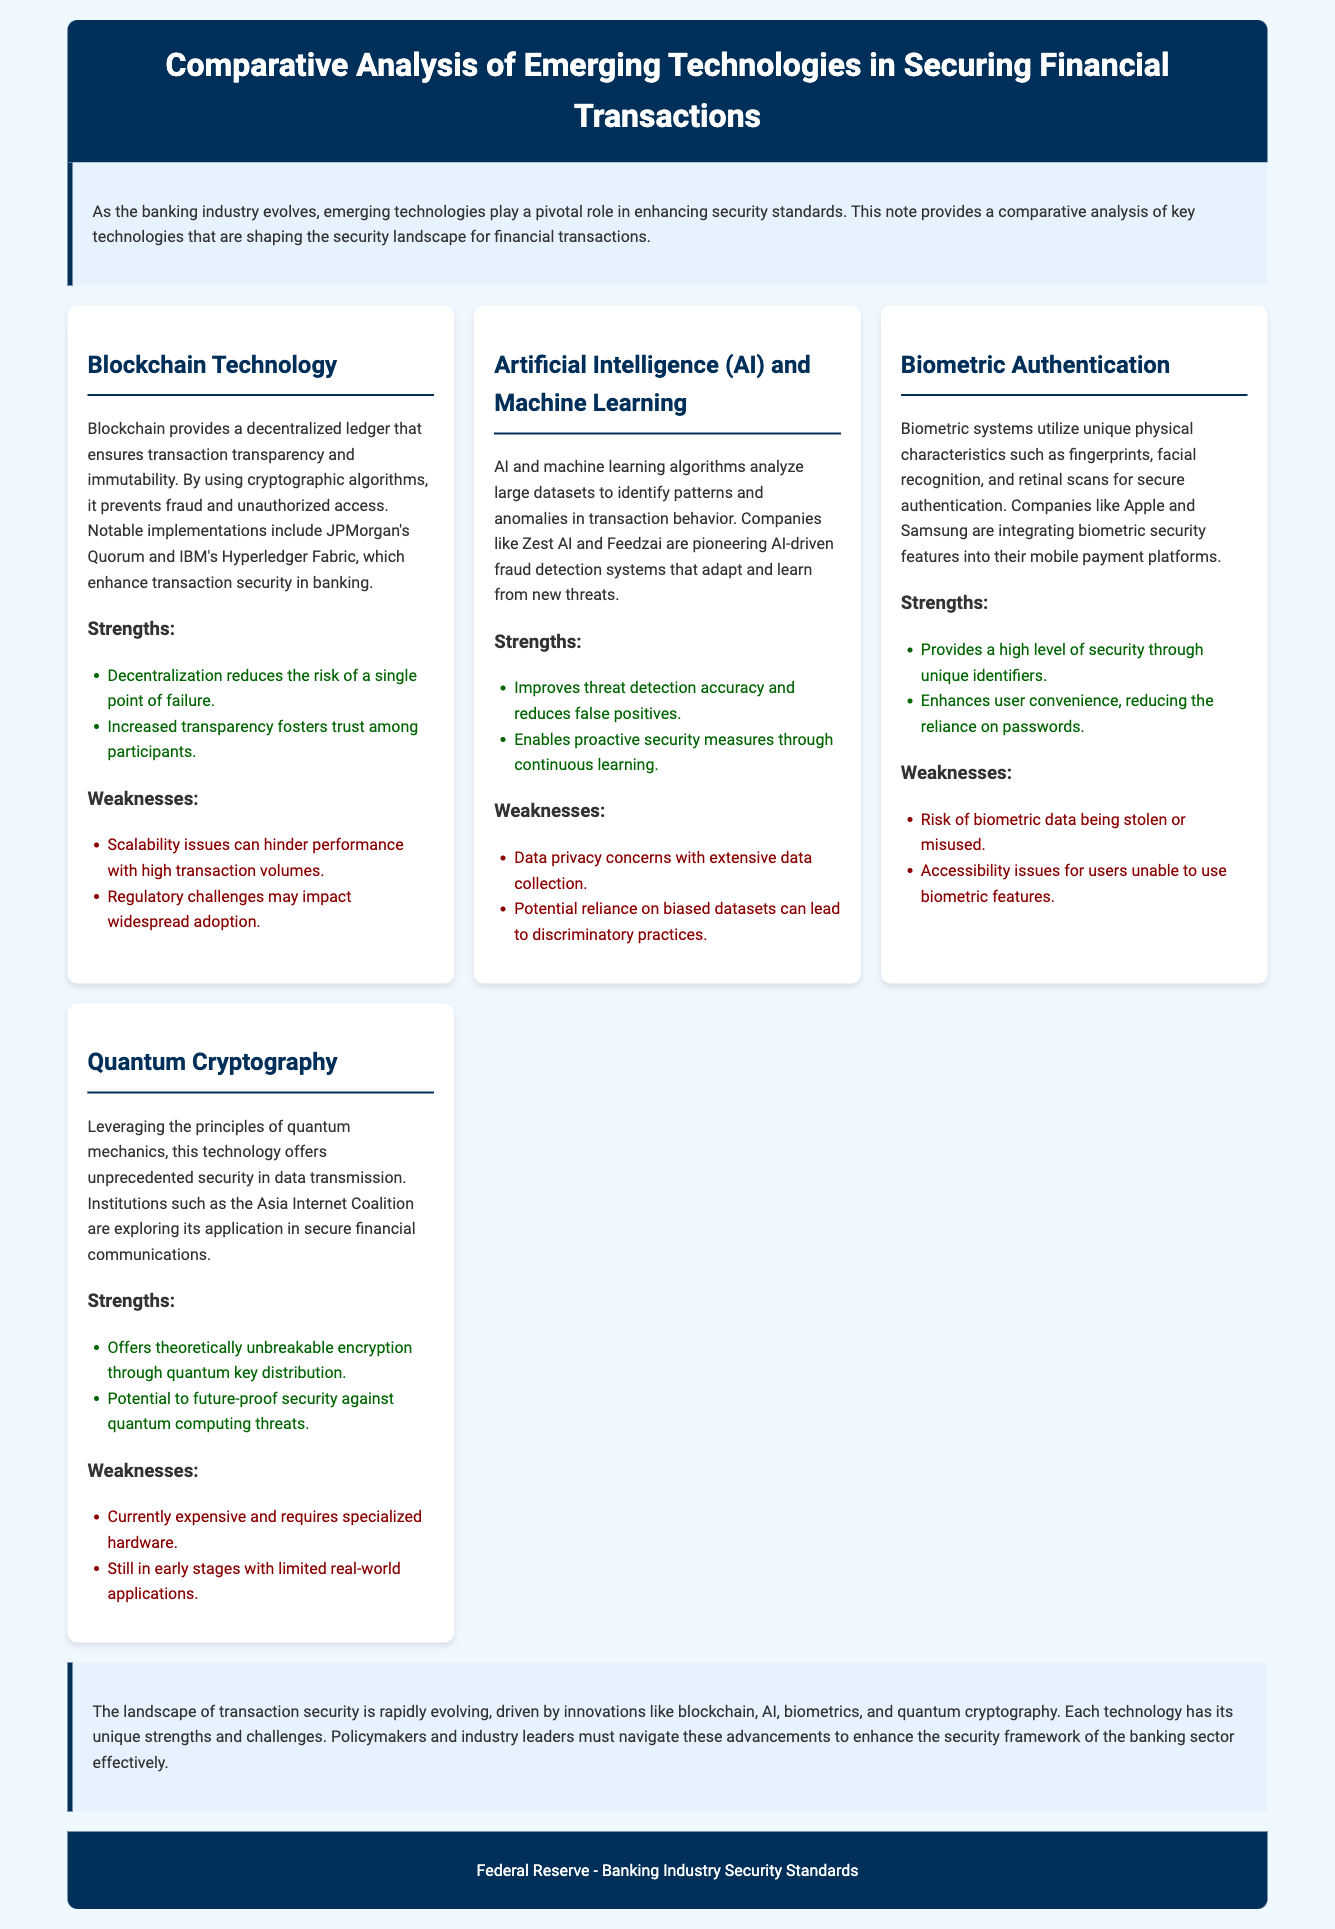What is the primary focus of the note? The primary focus is the comparative analysis of emerging technologies that enhance security standards in the banking industry.
Answer: Comparative analysis of emerging technologies in securing financial transactions Which technology ensures transaction transparency and immutability? Blockchain provides a decentralized ledger that ensures transaction transparency and immutability.
Answer: Blockchain What is a notable implementation of AI in fraud detection? Companies like Zest AI and Feedzai are pioneering AI-driven fraud detection systems.
Answer: Zest AI and Feedzai What is the risk associated with biometric authentication? The risk includes biometric data being stolen or misused.
Answer: Stolen or misused data Which technology is described as offering theoretically unbreakable encryption? Quantum cryptography offers theoretically unbreakable encryption through quantum key distribution.
Answer: Quantum cryptography What strength does blockchain provide related to failure risk? Decentralization reduces the risk of a single point of failure.
Answer: Decentralization What potential issue can arise from AI's reliance on datasets? Potential reliance on biased datasets can lead to discriminatory practices.
Answer: Discriminatory practices Which emerging technology is still in its early stages with limited applications? Quantum cryptography is still in early stages with limited real-world applications.
Answer: Quantum cryptography What do the strengths of biometric systems enhance besides security? Biometric systems enhance user convenience.
Answer: User convenience 